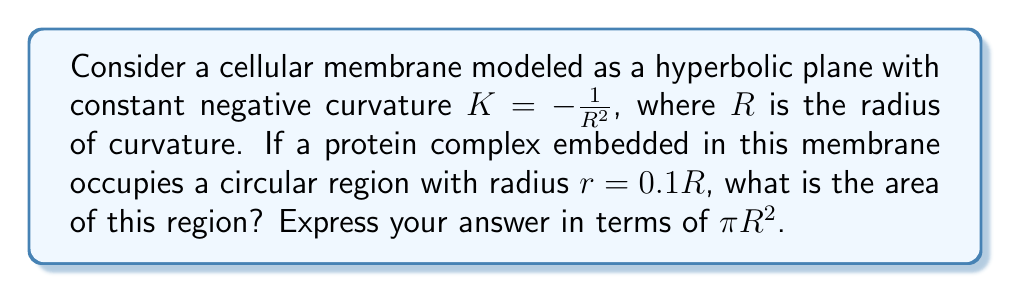Can you answer this question? To solve this problem, we'll follow these steps:

1) In hyperbolic geometry, the area of a circle is given by the formula:

   $$A = 4\pi R^2 \sinh^2(\frac{r}{2R})$$

   Where $R$ is the radius of curvature and $r$ is the radius of the circle.

2) We're given that $r = 0.1R$. Let's substitute this into our formula:

   $$A = 4\pi R^2 \sinh^2(\frac{0.1R}{2R})$$

3) Simplify the fraction inside sinh:

   $$A = 4\pi R^2 \sinh^2(0.05)$$

4) Now, we need to calculate $\sinh^2(0.05)$. We can use the Taylor series expansion of sinh:

   $$\sinh(x) = x + \frac{x^3}{3!} + \frac{x^5}{5!} + ...$$

5) For small x, we can approximate this as:

   $$\sinh(x) \approx x + \frac{x^3}{6}$$

6) Therefore:

   $$\sinh^2(0.05) \approx (0.05 + \frac{0.05^3}{6})^2 \approx 0.05^2 = 0.0025$$

7) Substituting back into our area formula:

   $$A \approx 4\pi R^2 (0.0025) = 0.01\pi R^2$$

Thus, the area of the circular region is approximately $0.01\pi R^2$.
Answer: $0.01\pi R^2$ 